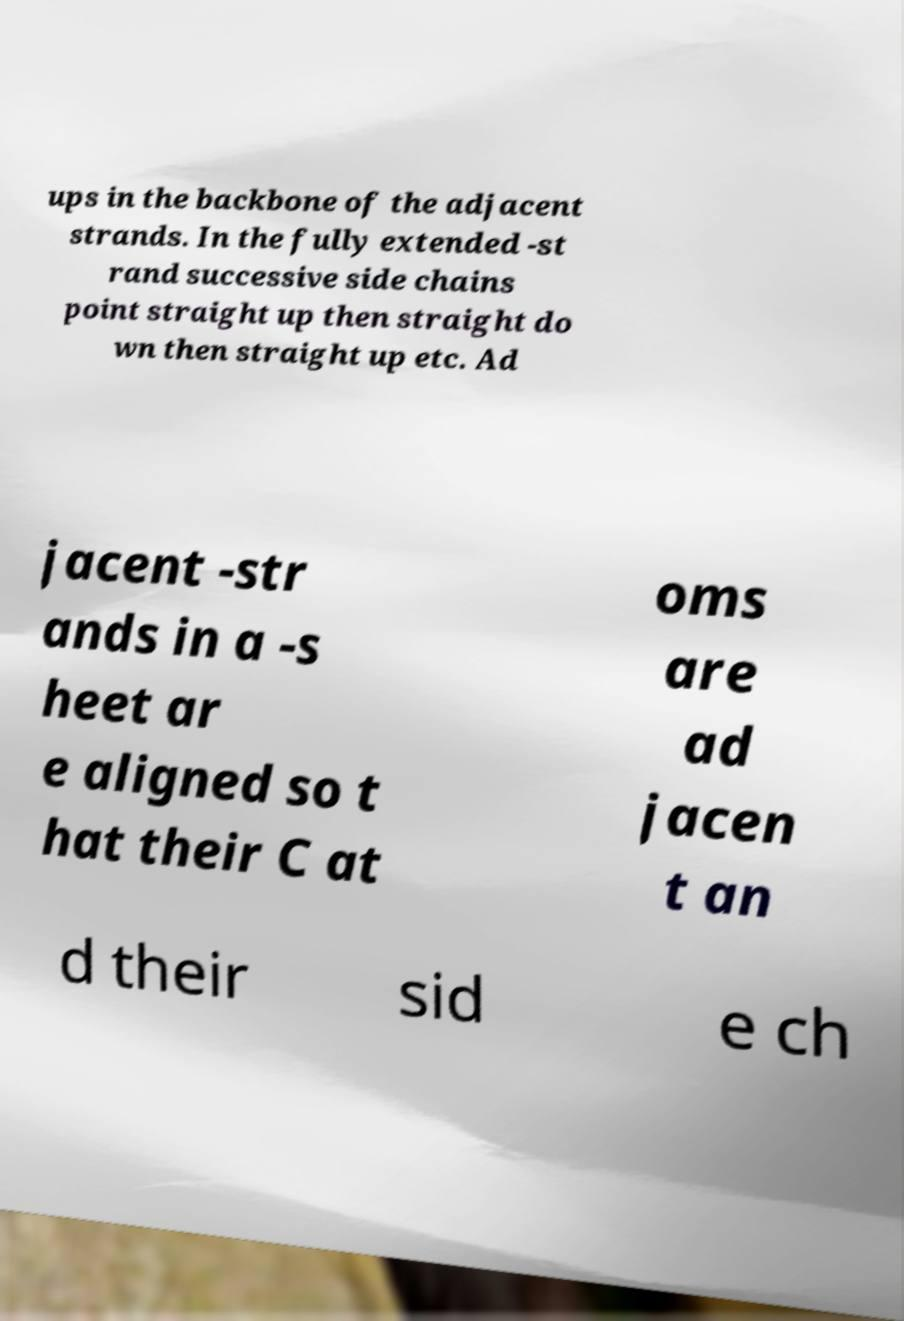For documentation purposes, I need the text within this image transcribed. Could you provide that? ups in the backbone of the adjacent strands. In the fully extended -st rand successive side chains point straight up then straight do wn then straight up etc. Ad jacent -str ands in a -s heet ar e aligned so t hat their C at oms are ad jacen t an d their sid e ch 